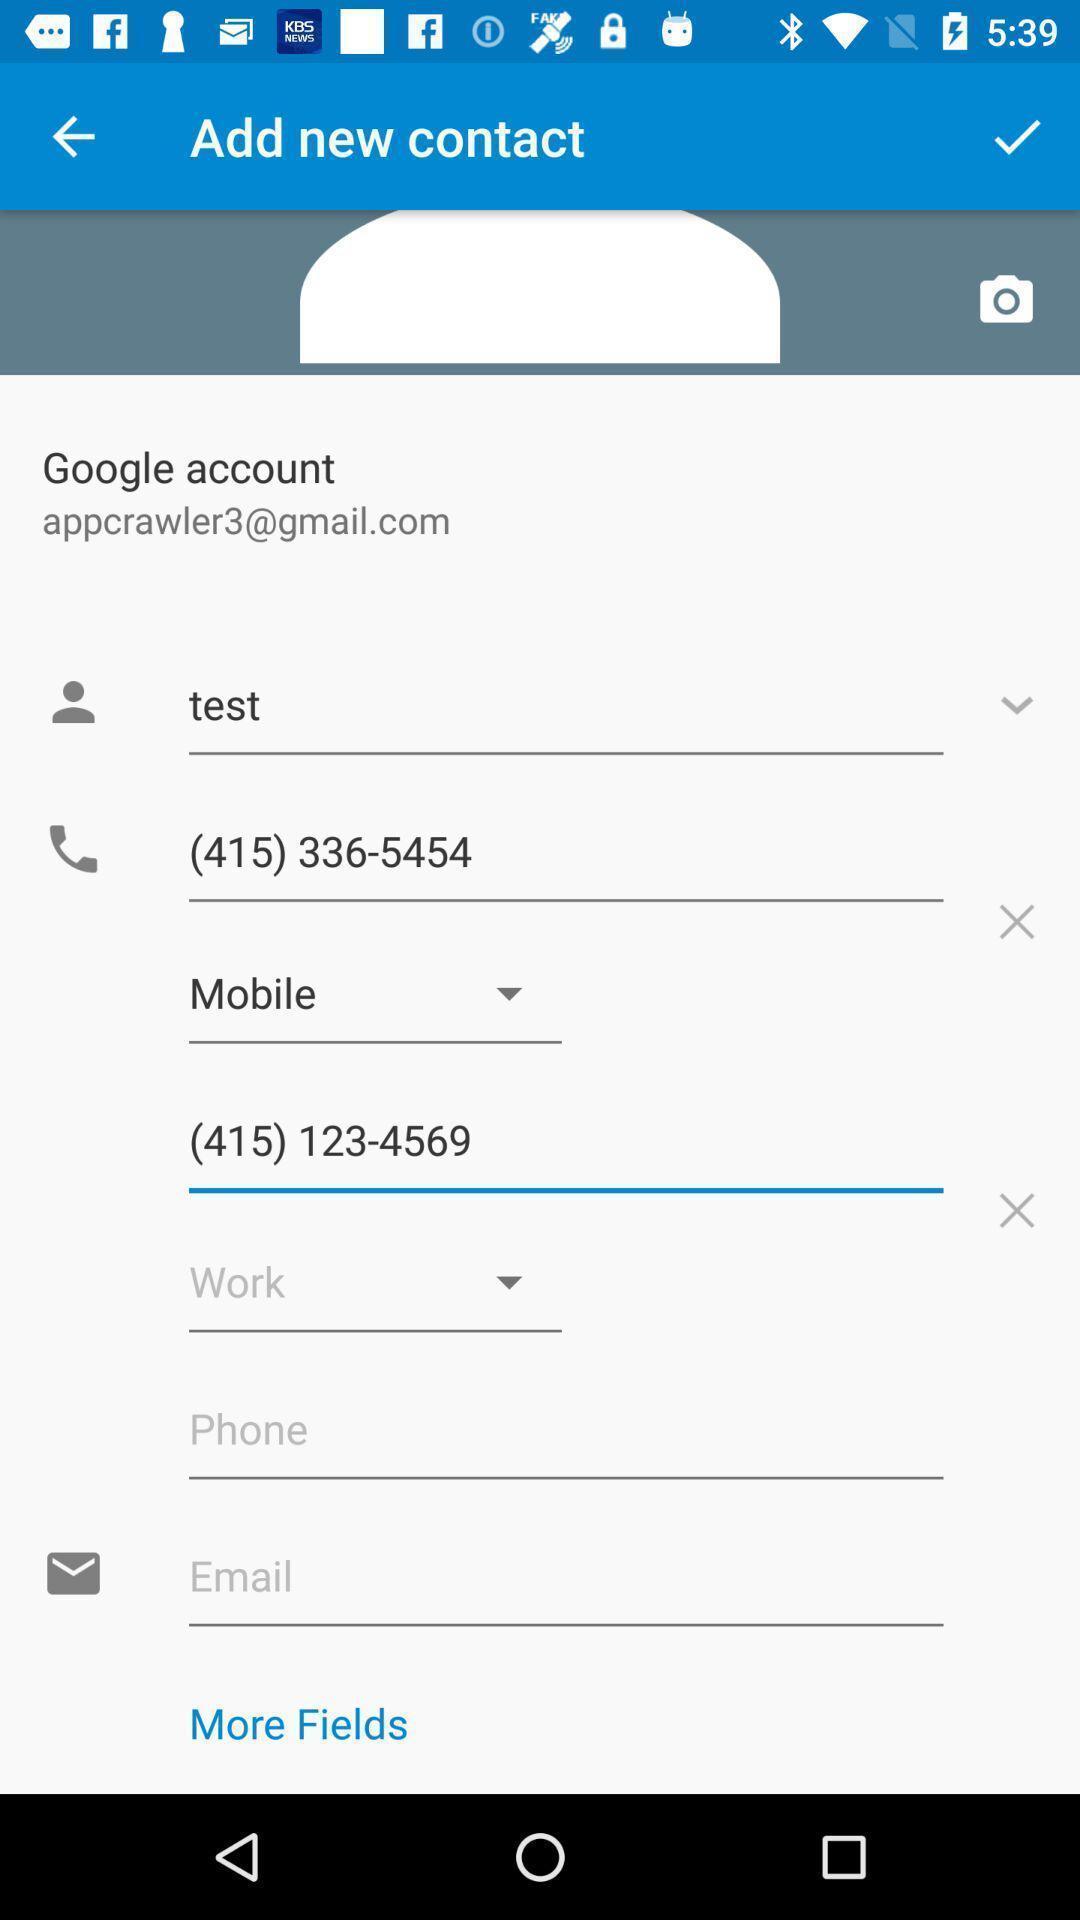Provide a detailed account of this screenshot. Page showing different options to enter. 